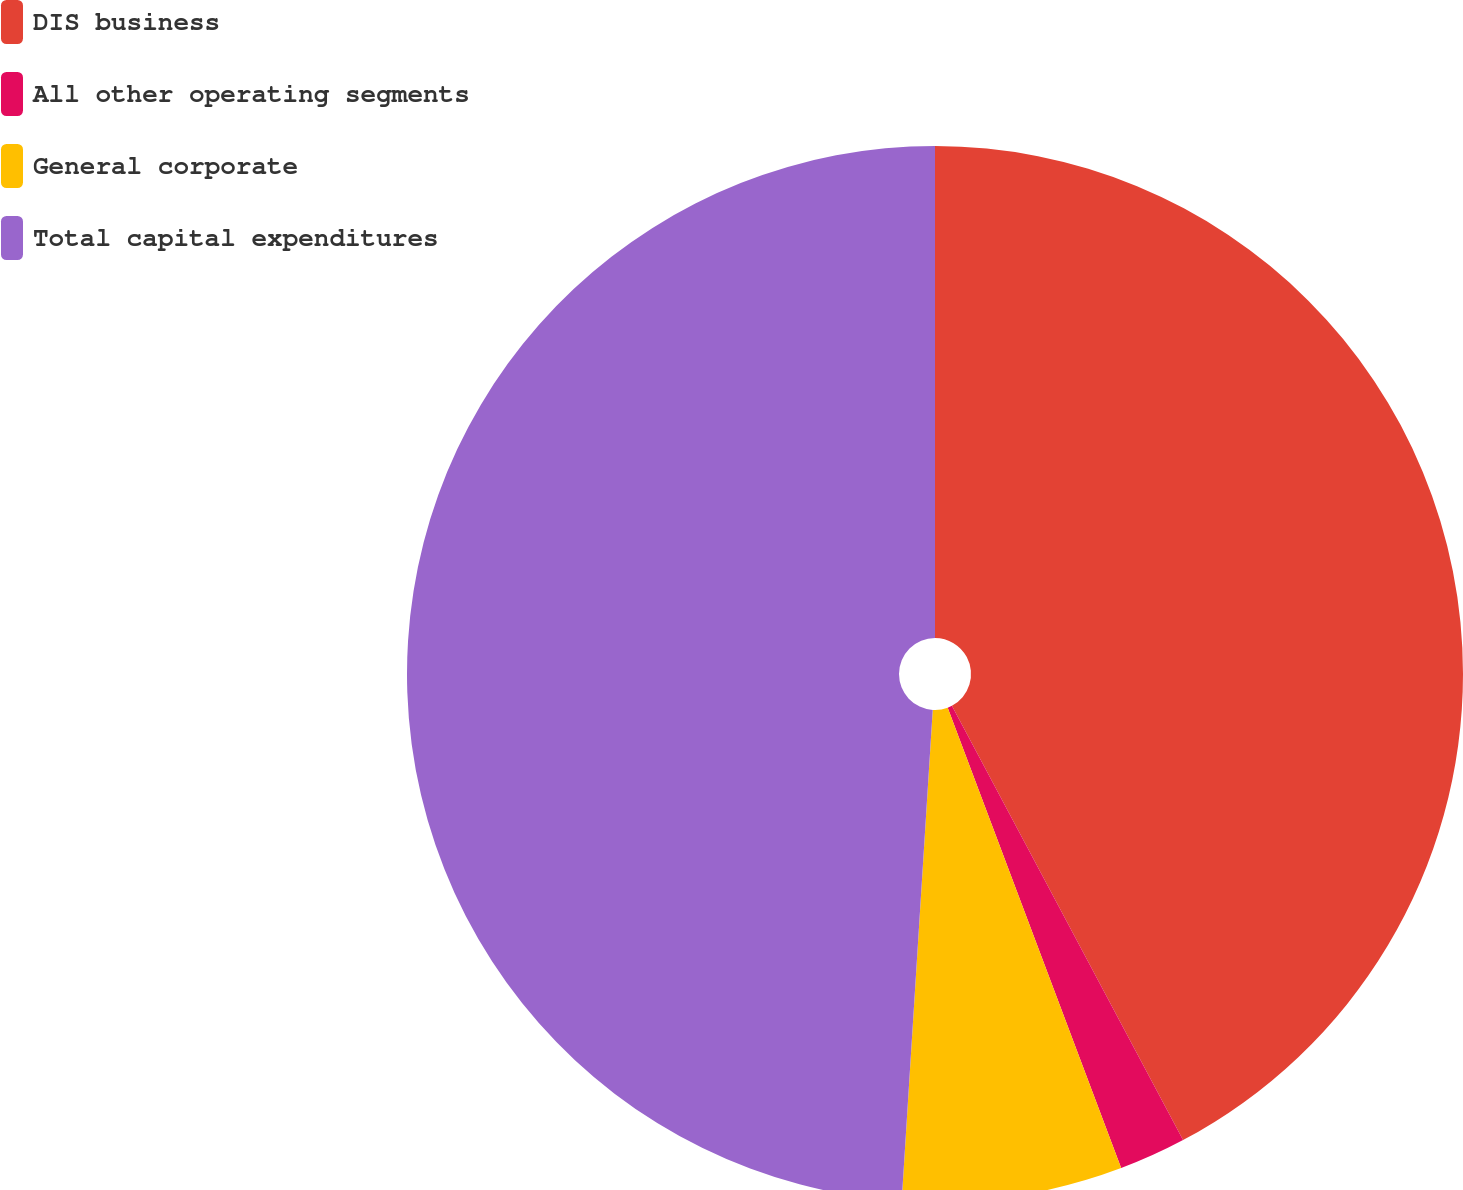<chart> <loc_0><loc_0><loc_500><loc_500><pie_chart><fcel>DIS business<fcel>All other operating segments<fcel>General corporate<fcel>Total capital expenditures<nl><fcel>42.22%<fcel>2.05%<fcel>6.74%<fcel>49.0%<nl></chart> 